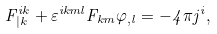<formula> <loc_0><loc_0><loc_500><loc_500>F ^ { i k } _ { | k } + \varepsilon ^ { i k m l } F _ { k m } \varphi _ { , l } = - 4 \pi j ^ { i } ,</formula> 